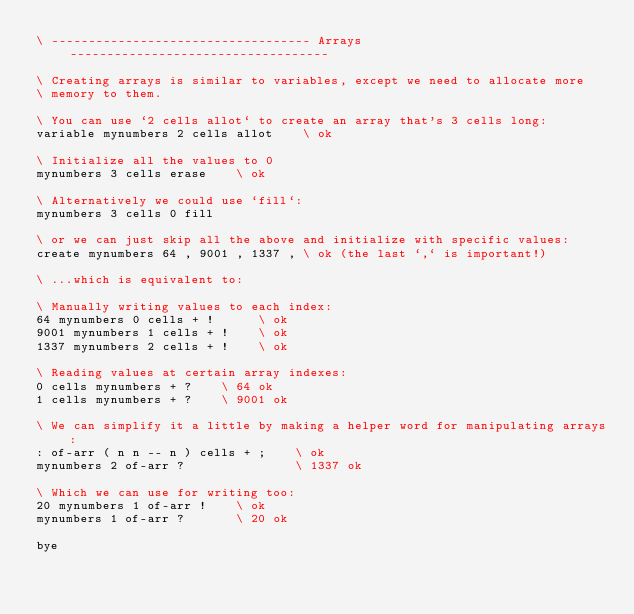Convert code to text. <code><loc_0><loc_0><loc_500><loc_500><_Forth_>\ ----------------------------------- Arrays -----------------------------------

\ Creating arrays is similar to variables, except we need to allocate more
\ memory to them.

\ You can use `2 cells allot` to create an array that's 3 cells long:
variable mynumbers 2 cells allot    \ ok

\ Initialize all the values to 0
mynumbers 3 cells erase    \ ok

\ Alternatively we could use `fill`:
mynumbers 3 cells 0 fill

\ or we can just skip all the above and initialize with specific values:
create mynumbers 64 , 9001 , 1337 , \ ok (the last `,` is important!)

\ ...which is equivalent to:

\ Manually writing values to each index:
64 mynumbers 0 cells + !      \ ok
9001 mynumbers 1 cells + !    \ ok
1337 mynumbers 2 cells + !    \ ok

\ Reading values at certain array indexes:
0 cells mynumbers + ?    \ 64 ok
1 cells mynumbers + ?    \ 9001 ok

\ We can simplify it a little by making a helper word for manipulating arrays:
: of-arr ( n n -- n ) cells + ;    \ ok
mynumbers 2 of-arr ?               \ 1337 ok

\ Which we can use for writing too:
20 mynumbers 1 of-arr !    \ ok
mynumbers 1 of-arr ?       \ 20 ok

bye
</code> 